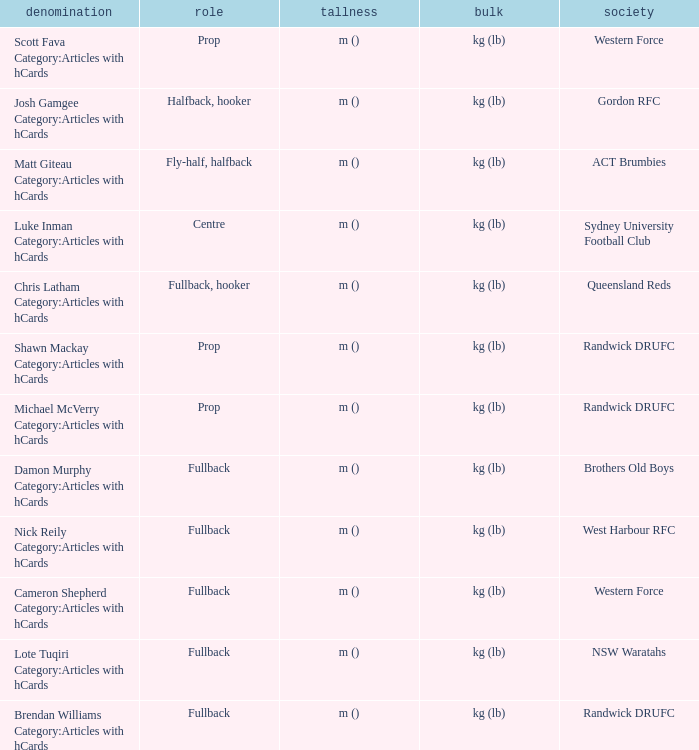Could you parse the entire table as a dict? {'header': ['denomination', 'role', 'tallness', 'bulk', 'society'], 'rows': [['Scott Fava Category:Articles with hCards', 'Prop', 'm ()', 'kg (lb)', 'Western Force'], ['Josh Gamgee Category:Articles with hCards', 'Halfback, hooker', 'm ()', 'kg (lb)', 'Gordon RFC'], ['Matt Giteau Category:Articles with hCards', 'Fly-half, halfback', 'm ()', 'kg (lb)', 'ACT Brumbies'], ['Luke Inman Category:Articles with hCards', 'Centre', 'm ()', 'kg (lb)', 'Sydney University Football Club'], ['Chris Latham Category:Articles with hCards', 'Fullback, hooker', 'm ()', 'kg (lb)', 'Queensland Reds'], ['Shawn Mackay Category:Articles with hCards', 'Prop', 'm ()', 'kg (lb)', 'Randwick DRUFC'], ['Michael McVerry Category:Articles with hCards', 'Prop', 'm ()', 'kg (lb)', 'Randwick DRUFC'], ['Damon Murphy Category:Articles with hCards', 'Fullback', 'm ()', 'kg (lb)', 'Brothers Old Boys'], ['Nick Reily Category:Articles with hCards', 'Fullback', 'm ()', 'kg (lb)', 'West Harbour RFC'], ['Cameron Shepherd Category:Articles with hCards', 'Fullback', 'm ()', 'kg (lb)', 'Western Force'], ['Lote Tuqiri Category:Articles with hCards', 'Fullback', 'm ()', 'kg (lb)', 'NSW Waratahs'], ['Brendan Williams Category:Articles with hCards', 'Fullback', 'm ()', 'kg (lb)', 'Randwick DRUFC']]} What is the name when the position was fullback, hooker? Chris Latham Category:Articles with hCards. 